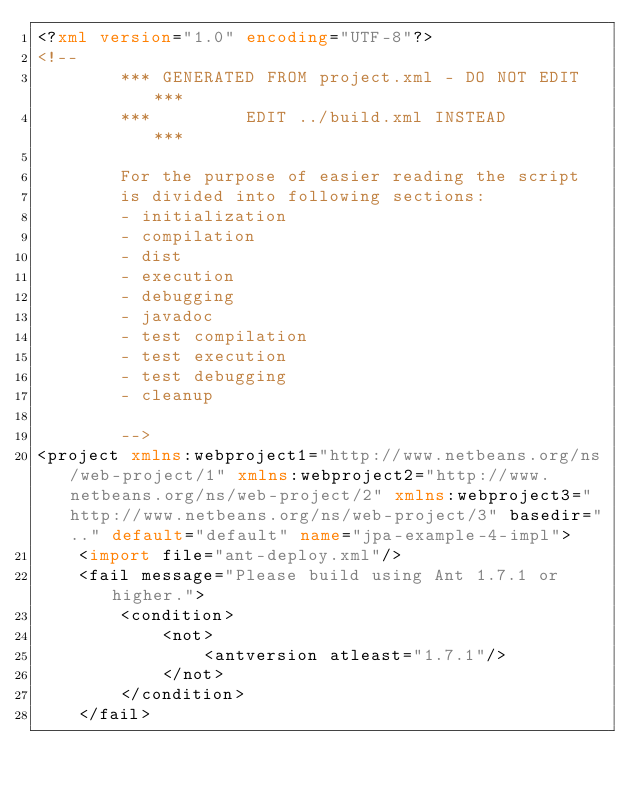Convert code to text. <code><loc_0><loc_0><loc_500><loc_500><_XML_><?xml version="1.0" encoding="UTF-8"?>
<!--
        *** GENERATED FROM project.xml - DO NOT EDIT  ***
        ***         EDIT ../build.xml INSTEAD         ***

        For the purpose of easier reading the script
        is divided into following sections:
        - initialization
        - compilation
        - dist
        - execution
        - debugging
        - javadoc
        - test compilation
        - test execution
        - test debugging
        - cleanup

        -->
<project xmlns:webproject1="http://www.netbeans.org/ns/web-project/1" xmlns:webproject2="http://www.netbeans.org/ns/web-project/2" xmlns:webproject3="http://www.netbeans.org/ns/web-project/3" basedir=".." default="default" name="jpa-example-4-impl">
    <import file="ant-deploy.xml"/>
    <fail message="Please build using Ant 1.7.1 or higher.">
        <condition>
            <not>
                <antversion atleast="1.7.1"/>
            </not>
        </condition>
    </fail></code> 